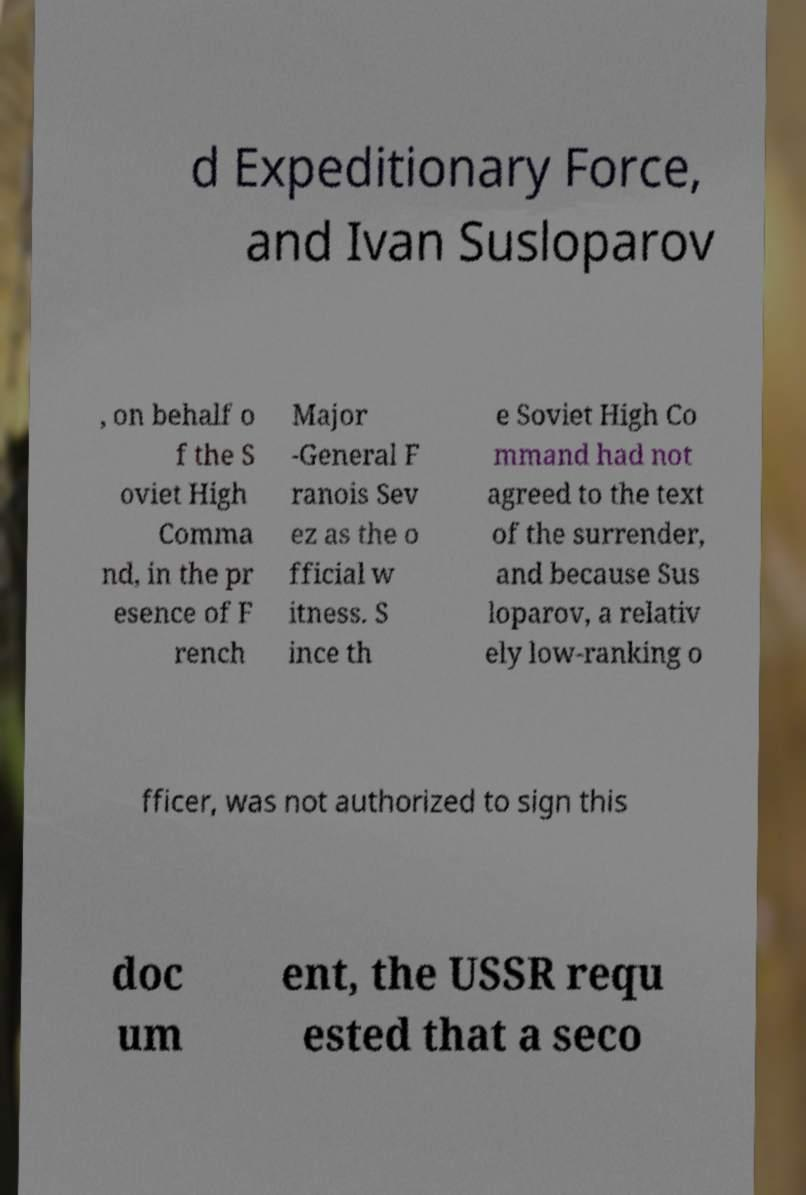Please identify and transcribe the text found in this image. d Expeditionary Force, and Ivan Susloparov , on behalf o f the S oviet High Comma nd, in the pr esence of F rench Major -General F ranois Sev ez as the o fficial w itness. S ince th e Soviet High Co mmand had not agreed to the text of the surrender, and because Sus loparov, a relativ ely low-ranking o fficer, was not authorized to sign this doc um ent, the USSR requ ested that a seco 